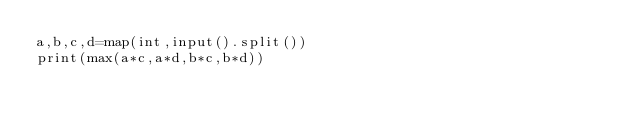Convert code to text. <code><loc_0><loc_0><loc_500><loc_500><_Python_>a,b,c,d=map(int,input().split())
print(max(a*c,a*d,b*c,b*d))</code> 